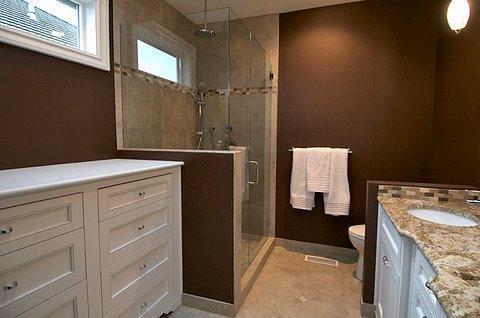How many towels are in this photo?
Give a very brief answer. 3. How many towels are hanging?
Give a very brief answer. 3. 